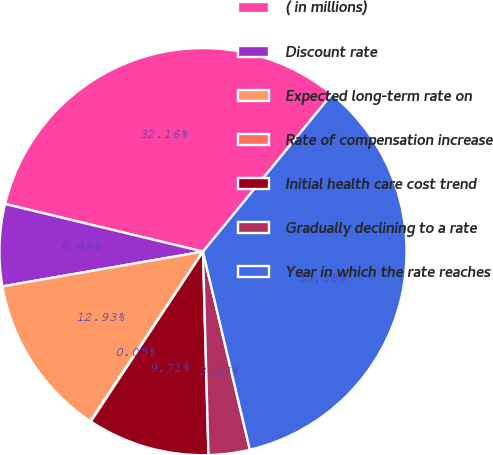Convert chart. <chart><loc_0><loc_0><loc_500><loc_500><pie_chart><fcel>( in millions)<fcel>Discount rate<fcel>Expected long-term rate on<fcel>Rate of compensation increase<fcel>Initial health care cost trend<fcel>Gradually declining to a rate<fcel>Year in which the rate reaches<nl><fcel>32.15%<fcel>6.49%<fcel>12.93%<fcel>0.05%<fcel>9.71%<fcel>3.27%<fcel>35.37%<nl></chart> 